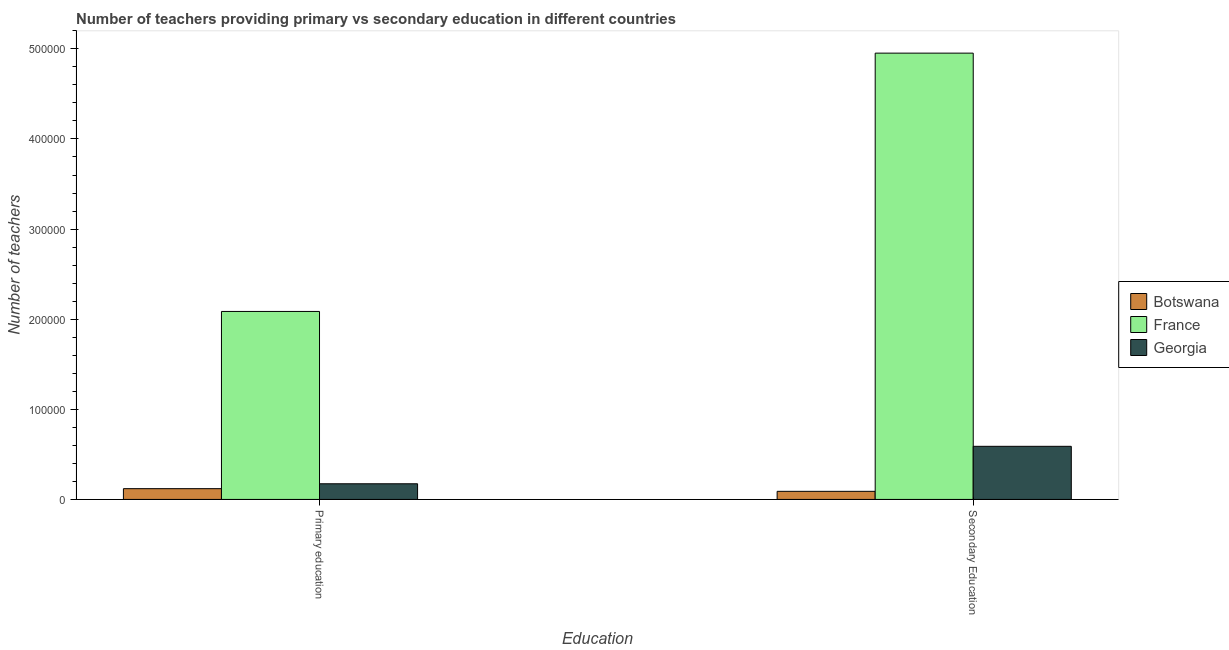How many groups of bars are there?
Your answer should be very brief. 2. Are the number of bars per tick equal to the number of legend labels?
Keep it short and to the point. Yes. Are the number of bars on each tick of the X-axis equal?
Give a very brief answer. Yes. How many bars are there on the 2nd tick from the left?
Make the answer very short. 3. How many bars are there on the 2nd tick from the right?
Your answer should be compact. 3. What is the label of the 2nd group of bars from the left?
Your response must be concise. Secondary Education. What is the number of secondary teachers in Georgia?
Keep it short and to the point. 5.89e+04. Across all countries, what is the maximum number of secondary teachers?
Offer a terse response. 4.95e+05. Across all countries, what is the minimum number of primary teachers?
Offer a very short reply. 1.20e+04. In which country was the number of secondary teachers minimum?
Your answer should be compact. Botswana. What is the total number of secondary teachers in the graph?
Ensure brevity in your answer.  5.63e+05. What is the difference between the number of primary teachers in France and that in Georgia?
Your answer should be compact. 1.91e+05. What is the difference between the number of secondary teachers in Botswana and the number of primary teachers in France?
Your answer should be very brief. -2.00e+05. What is the average number of secondary teachers per country?
Provide a succinct answer. 1.88e+05. What is the difference between the number of primary teachers and number of secondary teachers in Botswana?
Offer a very short reply. 2974. In how many countries, is the number of secondary teachers greater than 120000 ?
Offer a terse response. 1. What is the ratio of the number of primary teachers in France to that in Georgia?
Keep it short and to the point. 12.01. What does the 3rd bar from the left in Primary education represents?
Provide a short and direct response. Georgia. What does the 2nd bar from the right in Primary education represents?
Offer a very short reply. France. Are all the bars in the graph horizontal?
Your answer should be very brief. No. What is the difference between two consecutive major ticks on the Y-axis?
Ensure brevity in your answer.  1.00e+05. Where does the legend appear in the graph?
Offer a terse response. Center right. How are the legend labels stacked?
Offer a terse response. Vertical. What is the title of the graph?
Offer a terse response. Number of teachers providing primary vs secondary education in different countries. Does "Low & middle income" appear as one of the legend labels in the graph?
Ensure brevity in your answer.  No. What is the label or title of the X-axis?
Provide a succinct answer. Education. What is the label or title of the Y-axis?
Provide a short and direct response. Number of teachers. What is the Number of teachers in Botswana in Primary education?
Your answer should be very brief. 1.20e+04. What is the Number of teachers in France in Primary education?
Your answer should be compact. 2.09e+05. What is the Number of teachers of Georgia in Primary education?
Offer a very short reply. 1.74e+04. What is the Number of teachers in Botswana in Secondary Education?
Make the answer very short. 8976. What is the Number of teachers in France in Secondary Education?
Provide a succinct answer. 4.95e+05. What is the Number of teachers in Georgia in Secondary Education?
Keep it short and to the point. 5.89e+04. Across all Education, what is the maximum Number of teachers of Botswana?
Give a very brief answer. 1.20e+04. Across all Education, what is the maximum Number of teachers in France?
Provide a short and direct response. 4.95e+05. Across all Education, what is the maximum Number of teachers in Georgia?
Offer a very short reply. 5.89e+04. Across all Education, what is the minimum Number of teachers in Botswana?
Give a very brief answer. 8976. Across all Education, what is the minimum Number of teachers in France?
Provide a succinct answer. 2.09e+05. Across all Education, what is the minimum Number of teachers in Georgia?
Your response must be concise. 1.74e+04. What is the total Number of teachers in Botswana in the graph?
Keep it short and to the point. 2.09e+04. What is the total Number of teachers of France in the graph?
Your response must be concise. 7.04e+05. What is the total Number of teachers of Georgia in the graph?
Your answer should be compact. 7.63e+04. What is the difference between the Number of teachers in Botswana in Primary education and that in Secondary Education?
Your response must be concise. 2974. What is the difference between the Number of teachers in France in Primary education and that in Secondary Education?
Your answer should be compact. -2.87e+05. What is the difference between the Number of teachers of Georgia in Primary education and that in Secondary Education?
Make the answer very short. -4.16e+04. What is the difference between the Number of teachers in Botswana in Primary education and the Number of teachers in France in Secondary Education?
Your answer should be compact. -4.83e+05. What is the difference between the Number of teachers in Botswana in Primary education and the Number of teachers in Georgia in Secondary Education?
Provide a short and direct response. -4.70e+04. What is the difference between the Number of teachers in France in Primary education and the Number of teachers in Georgia in Secondary Education?
Ensure brevity in your answer.  1.50e+05. What is the average Number of teachers of Botswana per Education?
Make the answer very short. 1.05e+04. What is the average Number of teachers in France per Education?
Keep it short and to the point. 3.52e+05. What is the average Number of teachers in Georgia per Education?
Give a very brief answer. 3.81e+04. What is the difference between the Number of teachers of Botswana and Number of teachers of France in Primary education?
Keep it short and to the point. -1.97e+05. What is the difference between the Number of teachers in Botswana and Number of teachers in Georgia in Primary education?
Your response must be concise. -5415. What is the difference between the Number of teachers of France and Number of teachers of Georgia in Primary education?
Make the answer very short. 1.91e+05. What is the difference between the Number of teachers in Botswana and Number of teachers in France in Secondary Education?
Ensure brevity in your answer.  -4.86e+05. What is the difference between the Number of teachers in Botswana and Number of teachers in Georgia in Secondary Education?
Offer a terse response. -5.00e+04. What is the difference between the Number of teachers in France and Number of teachers in Georgia in Secondary Education?
Provide a succinct answer. 4.36e+05. What is the ratio of the Number of teachers of Botswana in Primary education to that in Secondary Education?
Give a very brief answer. 1.33. What is the ratio of the Number of teachers in France in Primary education to that in Secondary Education?
Make the answer very short. 0.42. What is the ratio of the Number of teachers in Georgia in Primary education to that in Secondary Education?
Provide a short and direct response. 0.29. What is the difference between the highest and the second highest Number of teachers of Botswana?
Provide a succinct answer. 2974. What is the difference between the highest and the second highest Number of teachers in France?
Your answer should be compact. 2.87e+05. What is the difference between the highest and the second highest Number of teachers of Georgia?
Provide a short and direct response. 4.16e+04. What is the difference between the highest and the lowest Number of teachers of Botswana?
Provide a succinct answer. 2974. What is the difference between the highest and the lowest Number of teachers in France?
Your response must be concise. 2.87e+05. What is the difference between the highest and the lowest Number of teachers in Georgia?
Make the answer very short. 4.16e+04. 